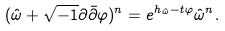Convert formula to latex. <formula><loc_0><loc_0><loc_500><loc_500>( { \hat { \omega } } + \sqrt { - 1 } \partial \bar { \partial } \varphi ) ^ { n } = e ^ { h _ { \hat { \omega } } - t \varphi } { \hat { \omega } } ^ { n } .</formula> 